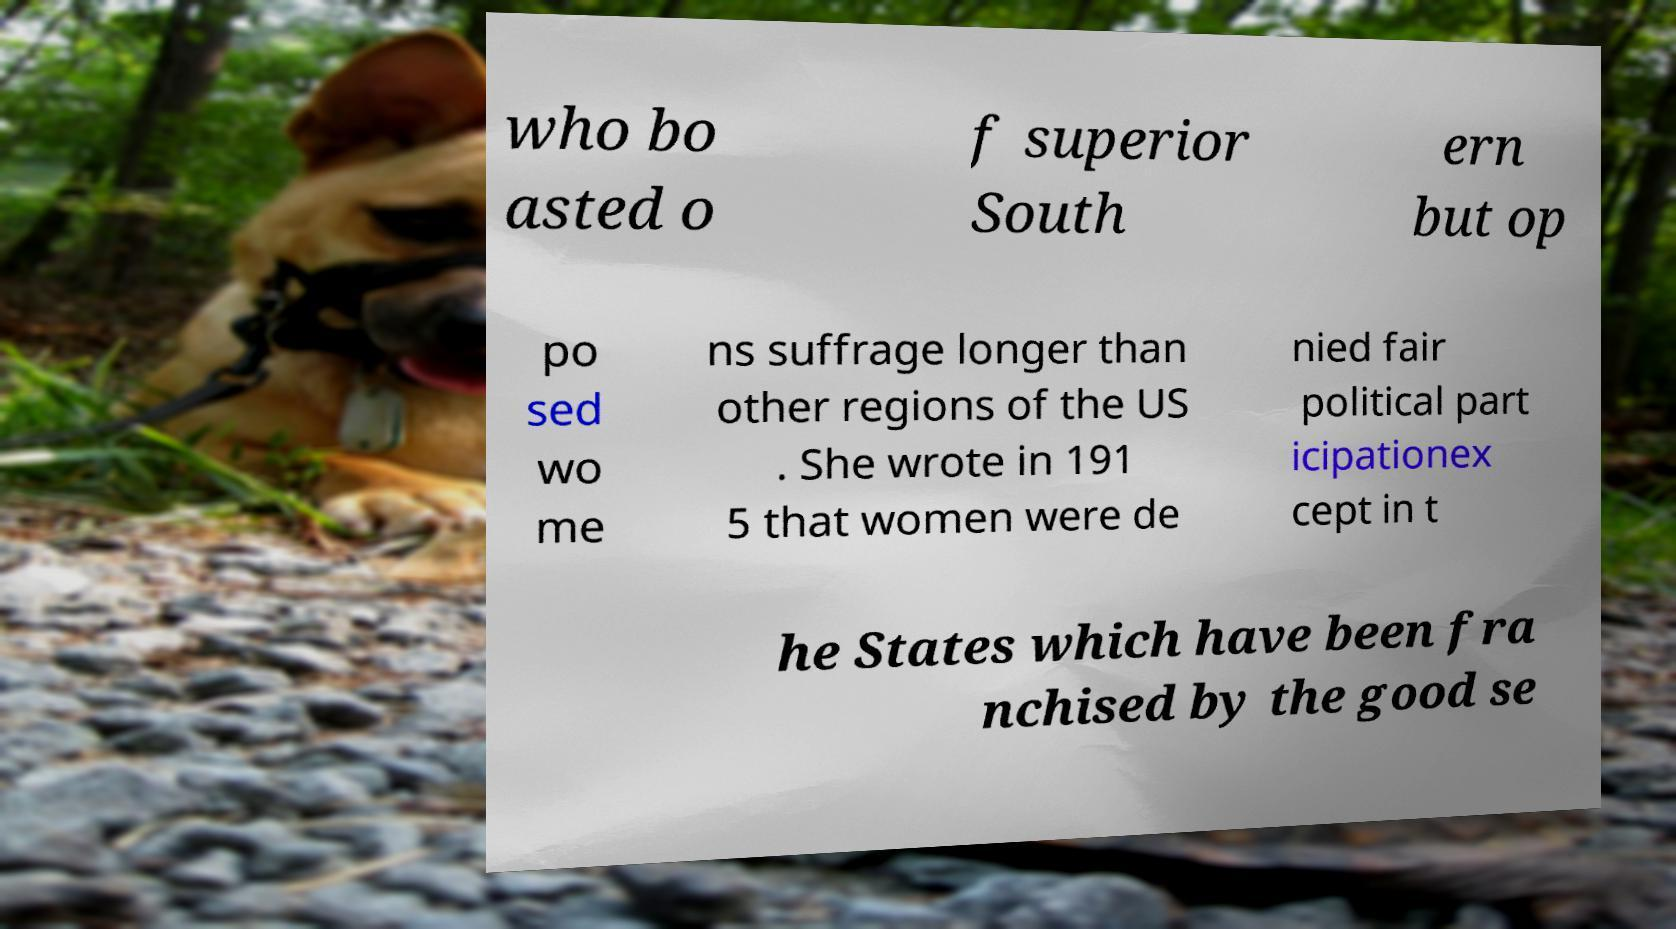Can you accurately transcribe the text from the provided image for me? who bo asted o f superior South ern but op po sed wo me ns suffrage longer than other regions of the US . She wrote in 191 5 that women were de nied fair political part icipationex cept in t he States which have been fra nchised by the good se 